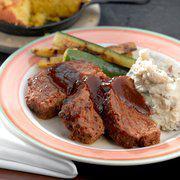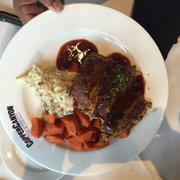The first image is the image on the left, the second image is the image on the right. Analyze the images presented: Is the assertion "The food in the image on the right is being served in a blue and white dish." valid? Answer yes or no. No. The first image is the image on the left, the second image is the image on the right. For the images shown, is this caption "At least one image shows green beans next to meatloaf on a plate, and one plate has a royal blue band around it rimmed with red." true? Answer yes or no. No. 